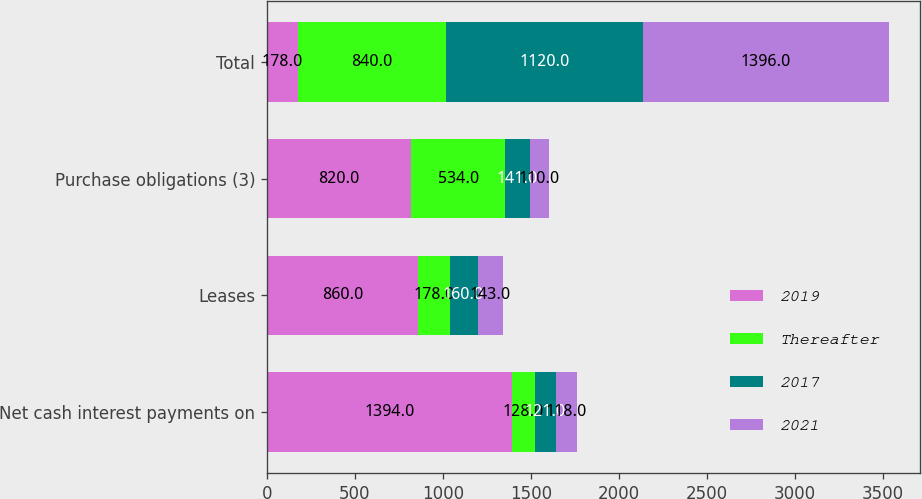<chart> <loc_0><loc_0><loc_500><loc_500><stacked_bar_chart><ecel><fcel>Net cash interest payments on<fcel>Leases<fcel>Purchase obligations (3)<fcel>Total<nl><fcel>2019<fcel>1394<fcel>860<fcel>820<fcel>178<nl><fcel>Thereafter<fcel>128<fcel>178<fcel>534<fcel>840<nl><fcel>2017<fcel>121<fcel>160<fcel>141<fcel>1120<nl><fcel>2021<fcel>118<fcel>143<fcel>110<fcel>1396<nl></chart> 